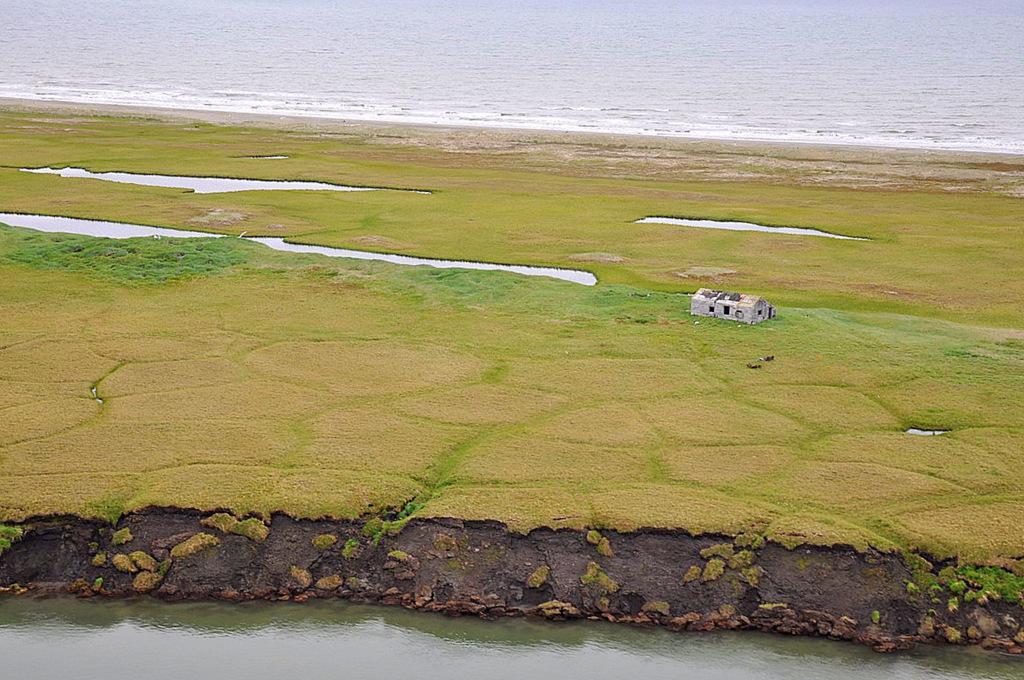Please provide a concise description of this image. In this image we can see a house, grass and also the water. We can also see the beach at the top. 